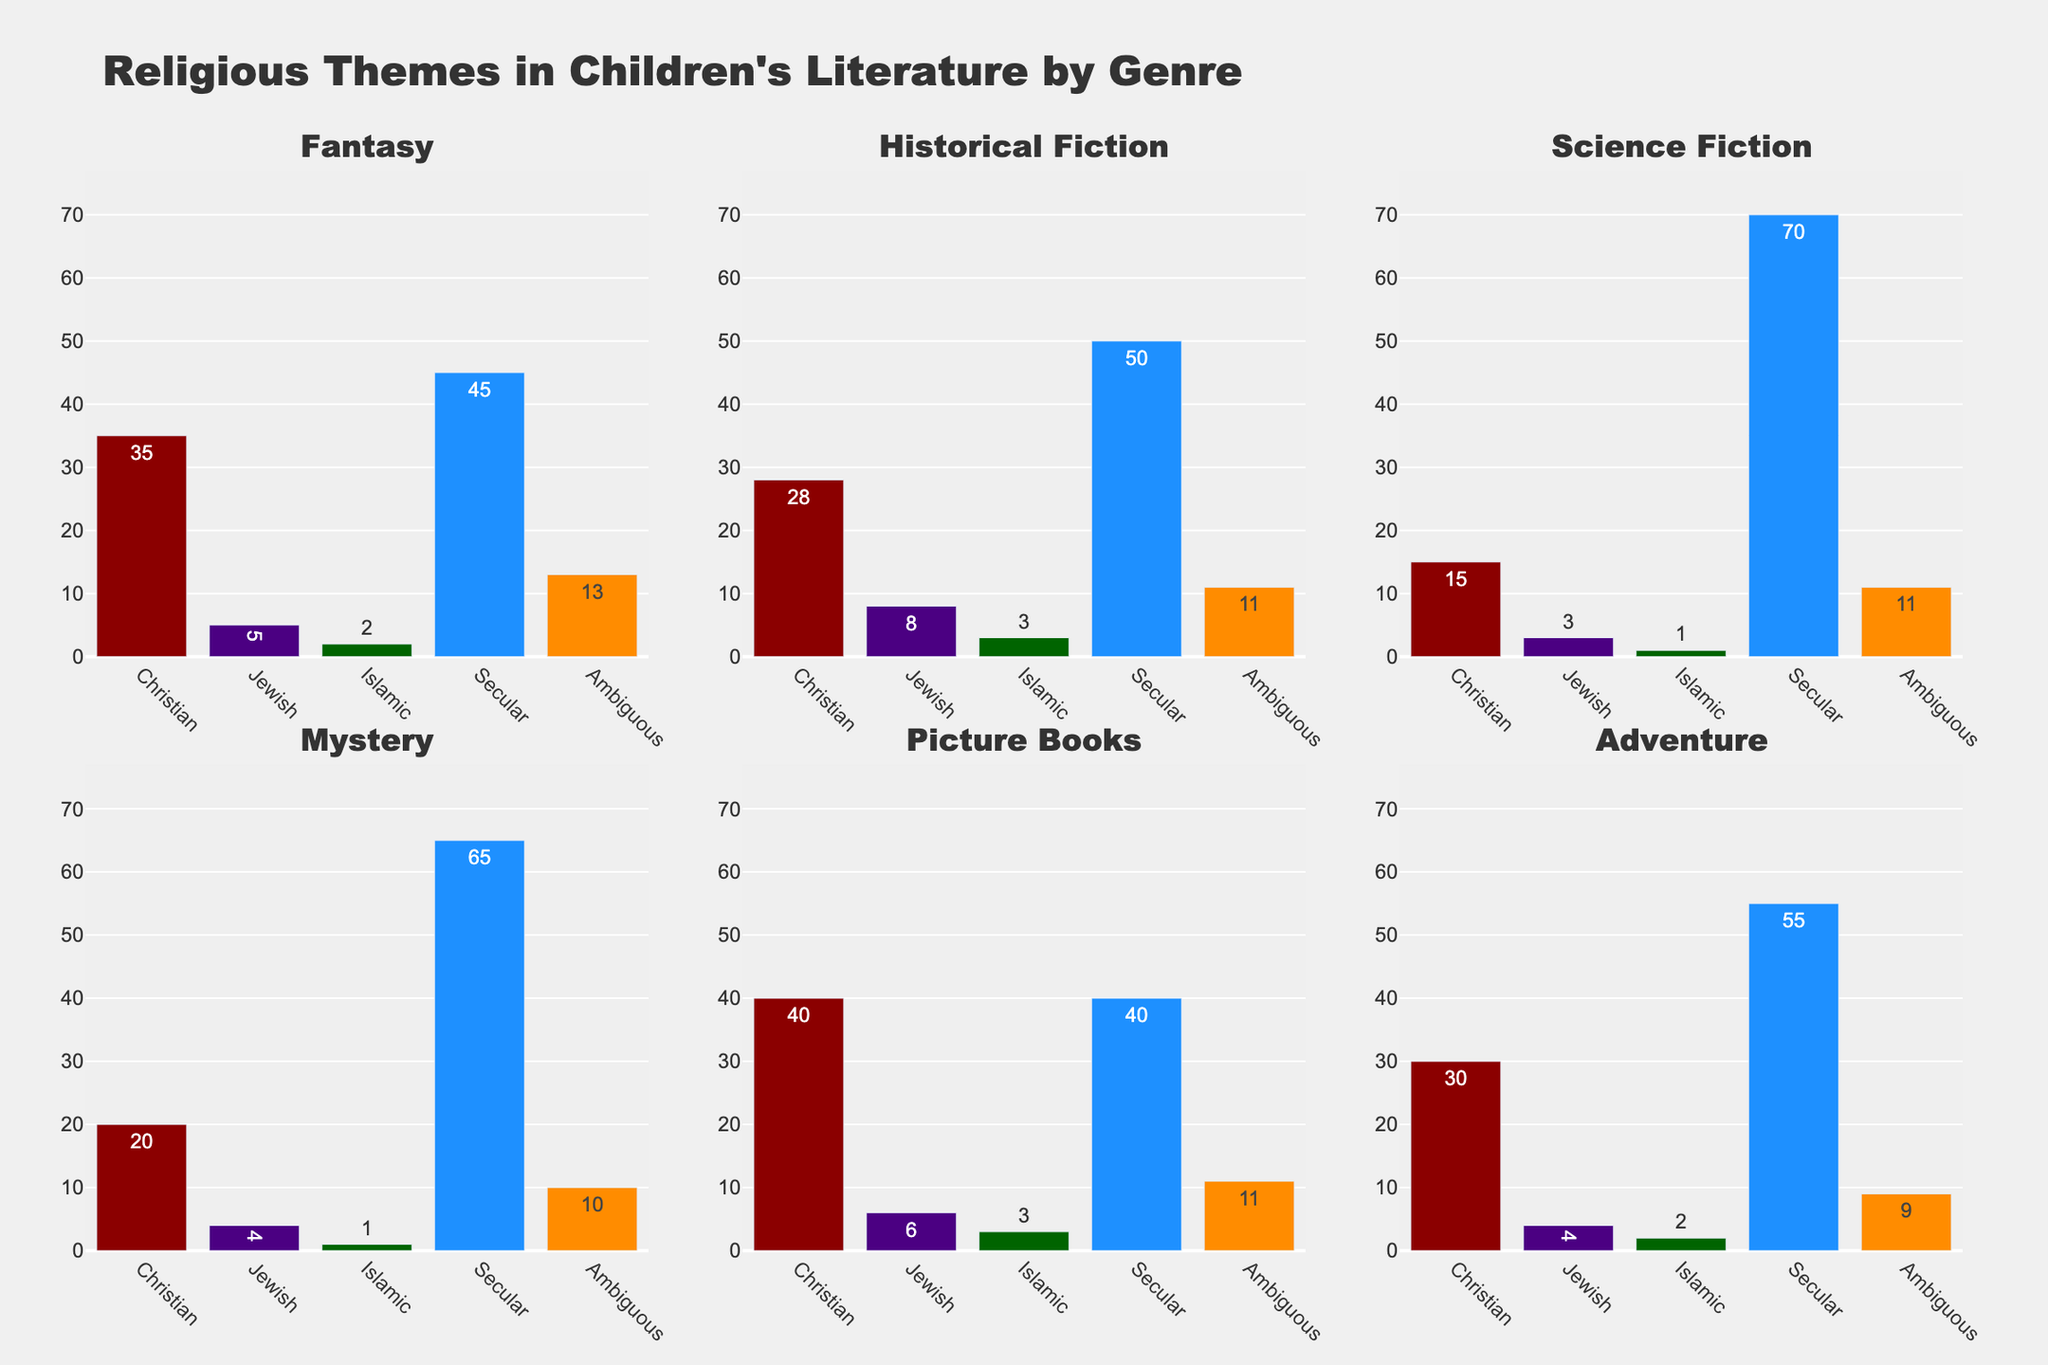What's the most common religious theme in science fiction? By examining the subplot for Science Fiction, the tallest bar, representing the most common theme, is for Secular themes.
Answer: Secular In which genre is the Christian theme most prevalent? By looking across all subplots, Christian themes have the highest count in Picture Books with a value of 40.
Answer: Picture Books Which genre contains the highest count of Ambiguous themes? By scanning all subplots for the Ambiguous theme bars, the Fairy Tales genre has the highest count with a value of 21.
Answer: Fairy Tales How many genres have more than 50 Secular-themed books? By checking the heights of the Secular theme bars in each subplot, three genres (Science Fiction, Historical Fiction, Mystery) have more than 50 Secular-themed books.
Answer: Three What is the total number of Jewish-themed books in the first three genres combined? Add the counts for the Jewish themes in Fantasy (5), Historical Fiction (8), and Science Fiction (3). The sum is 5 + 8 + 3 = 16.
Answer: 16 How does the prevalence of Islamic themes in Mystery compare to that in Adventure? Compare the Islamic theme bars in the Mystery and Adventure subplots; both have the same count, which is 1 for Mystery and 2 for Adventure.
Answer: Adventure has more Which theme shows the least variation across all genres? By examining the spread of the bar heights across themes in all subplots, the Islamic theme shows the least variation, with values clustering closely around 1-5.
Answer: Islamic What is the difference between the number of Christian-themed and Secular-themed books in Fantasy? The Fantasy subplot shows 35 Christian-themed books and 45 Secular-themed books. The difference is 45 - 35 = 10.
Answer: 10 Which genre has the most balanced representation across all religious themes? By observing subplots where the heights of bars are relatively equal, Picture Books have more balanced counts for all themes.
Answer: Picture Books 